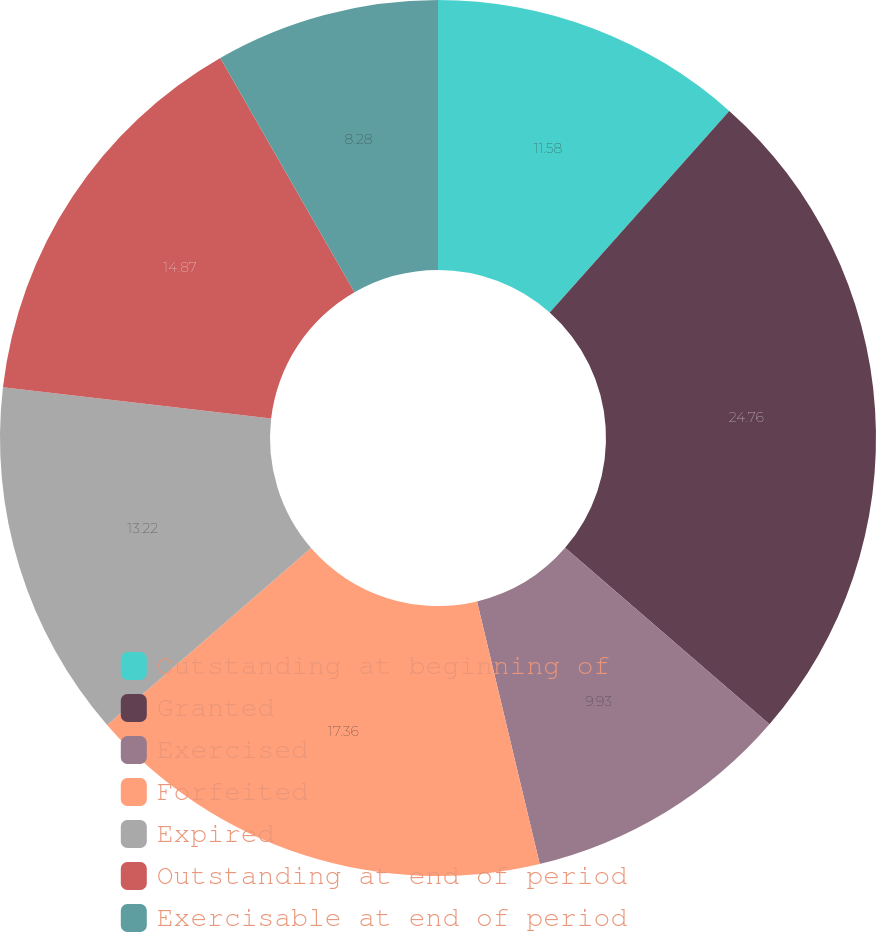Convert chart. <chart><loc_0><loc_0><loc_500><loc_500><pie_chart><fcel>Outstanding at beginning of<fcel>Granted<fcel>Exercised<fcel>Forfeited<fcel>Expired<fcel>Outstanding at end of period<fcel>Exercisable at end of period<nl><fcel>11.58%<fcel>24.76%<fcel>9.93%<fcel>17.36%<fcel>13.22%<fcel>14.87%<fcel>8.28%<nl></chart> 